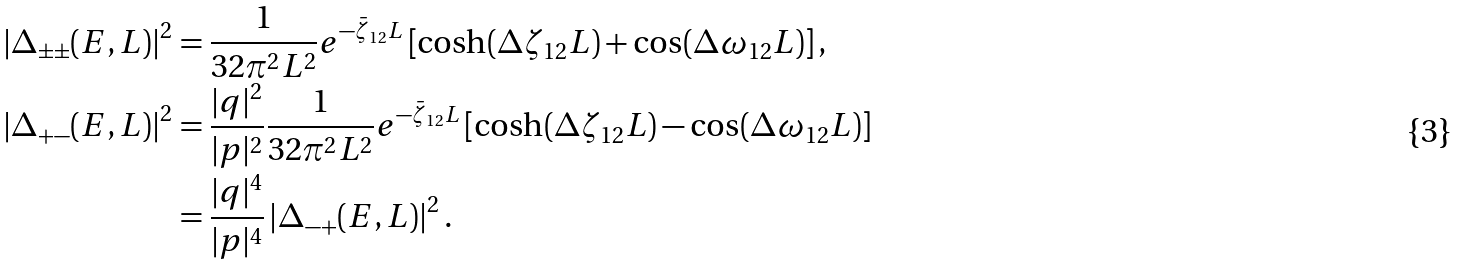<formula> <loc_0><loc_0><loc_500><loc_500>\left | \Delta _ { \pm \pm } ( E , L ) \right | ^ { 2 } & = \frac { 1 } { 3 2 \pi ^ { 2 } L ^ { 2 } } e ^ { - \bar { \zeta } _ { 1 2 } L } \left [ \cosh ( \Delta \zeta _ { 1 2 } L ) + \cos ( \Delta \omega _ { 1 2 } L ) \right ] , \\ \left | \Delta _ { + - } ( E , L ) \right | ^ { 2 } & = \frac { | q | ^ { 2 } } { | p | ^ { 2 } } \frac { 1 } { 3 2 \pi ^ { 2 } L ^ { 2 } } e ^ { - \bar { \zeta } _ { 1 2 } L } \left [ \cosh ( \Delta \zeta _ { 1 2 } L ) - \cos ( \Delta \omega _ { 1 2 } L ) \right ] \\ & = \frac { | q | ^ { 4 } } { | p | ^ { 4 } } \left | \Delta _ { - + } ( E , L ) \right | ^ { 2 } .</formula> 